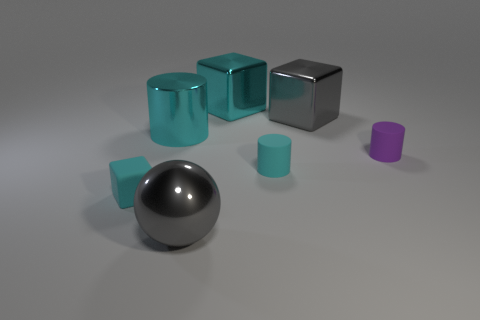What number of things are either cyan metal blocks or small blue cylinders?
Keep it short and to the point. 1. What shape is the large cyan thing that is the same material as the big cyan cylinder?
Provide a short and direct response. Cube. There is a cyan block to the left of the cyan metallic object that is behind the gray block; what size is it?
Provide a short and direct response. Small. What number of big objects are blue metal objects or metallic cubes?
Provide a succinct answer. 2. How many other objects are the same color as the big ball?
Make the answer very short. 1. Does the matte cylinder left of the purple matte thing have the same size as the block that is on the left side of the shiny sphere?
Give a very brief answer. Yes. Are the tiny cyan block and the cyan cylinder in front of the large cyan cylinder made of the same material?
Your response must be concise. Yes. Is the number of rubber cubes that are in front of the metal cylinder greater than the number of tiny cyan rubber blocks that are to the right of the small cyan block?
Give a very brief answer. Yes. There is a big metallic thing that is to the right of the large cyan block that is on the left side of the small purple object; what is its color?
Keep it short and to the point. Gray. What number of cylinders are either big things or large brown things?
Ensure brevity in your answer.  1. 